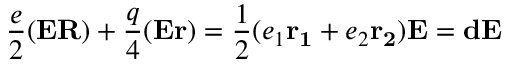<formula> <loc_0><loc_0><loc_500><loc_500>\frac { e } { 2 } ( { E } { R } ) + \frac { q } { 4 } ( { E } { r } ) = \frac { 1 } { 2 } ( e _ { 1 } { r _ { 1 } } + e _ { 2 } { r _ { 2 } } ) { E } = { d } { E }</formula> 